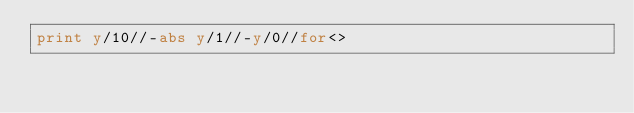<code> <loc_0><loc_0><loc_500><loc_500><_Perl_>print y/10//-abs y/1//-y/0//for<></code> 